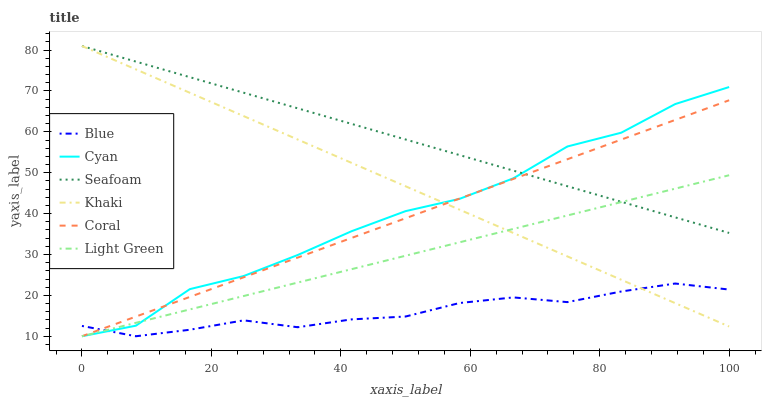Does Blue have the minimum area under the curve?
Answer yes or no. Yes. Does Seafoam have the maximum area under the curve?
Answer yes or no. Yes. Does Khaki have the minimum area under the curve?
Answer yes or no. No. Does Khaki have the maximum area under the curve?
Answer yes or no. No. Is Light Green the smoothest?
Answer yes or no. Yes. Is Cyan the roughest?
Answer yes or no. Yes. Is Khaki the smoothest?
Answer yes or no. No. Is Khaki the roughest?
Answer yes or no. No. Does Blue have the lowest value?
Answer yes or no. Yes. Does Khaki have the lowest value?
Answer yes or no. No. Does Seafoam have the highest value?
Answer yes or no. Yes. Does Coral have the highest value?
Answer yes or no. No. Is Blue less than Seafoam?
Answer yes or no. Yes. Is Seafoam greater than Blue?
Answer yes or no. Yes. Does Blue intersect Cyan?
Answer yes or no. Yes. Is Blue less than Cyan?
Answer yes or no. No. Is Blue greater than Cyan?
Answer yes or no. No. Does Blue intersect Seafoam?
Answer yes or no. No. 